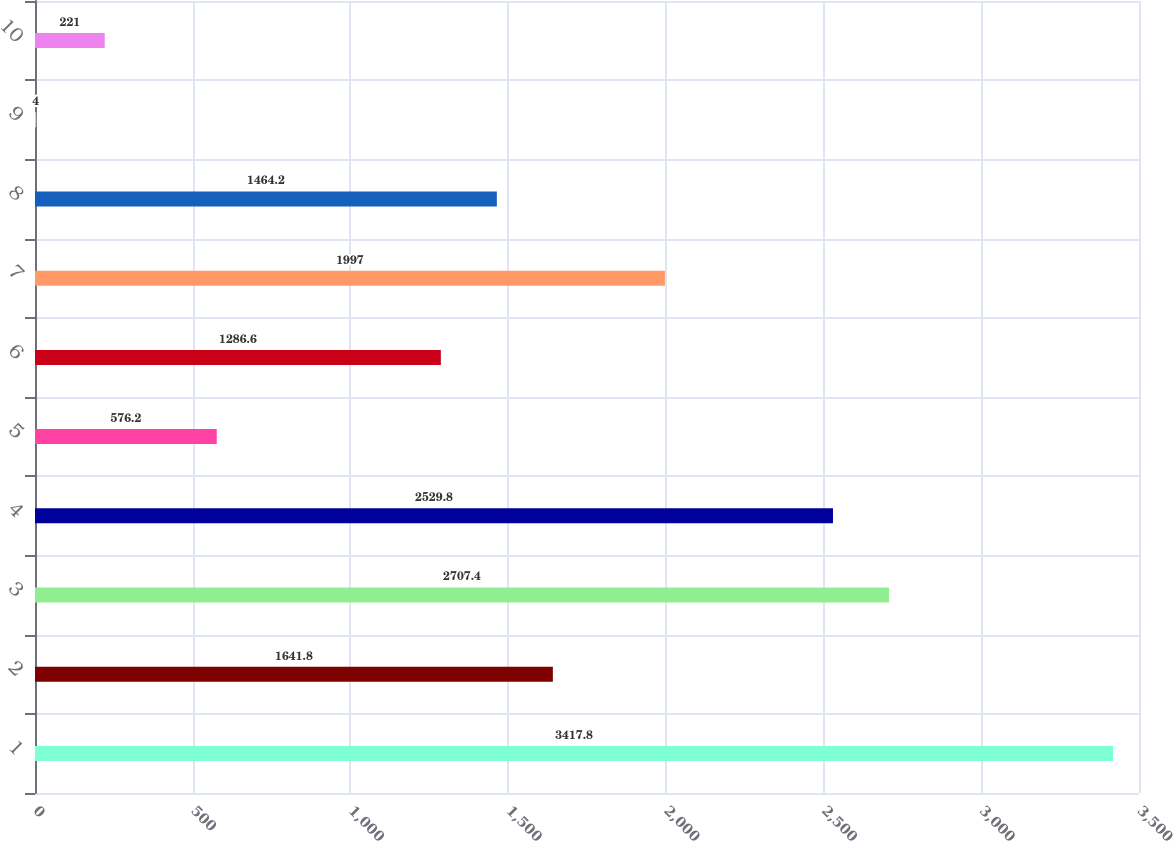<chart> <loc_0><loc_0><loc_500><loc_500><bar_chart><fcel>1<fcel>2<fcel>3<fcel>4<fcel>5<fcel>6<fcel>7<fcel>8<fcel>9<fcel>10<nl><fcel>3417.8<fcel>1641.8<fcel>2707.4<fcel>2529.8<fcel>576.2<fcel>1286.6<fcel>1997<fcel>1464.2<fcel>4<fcel>221<nl></chart> 